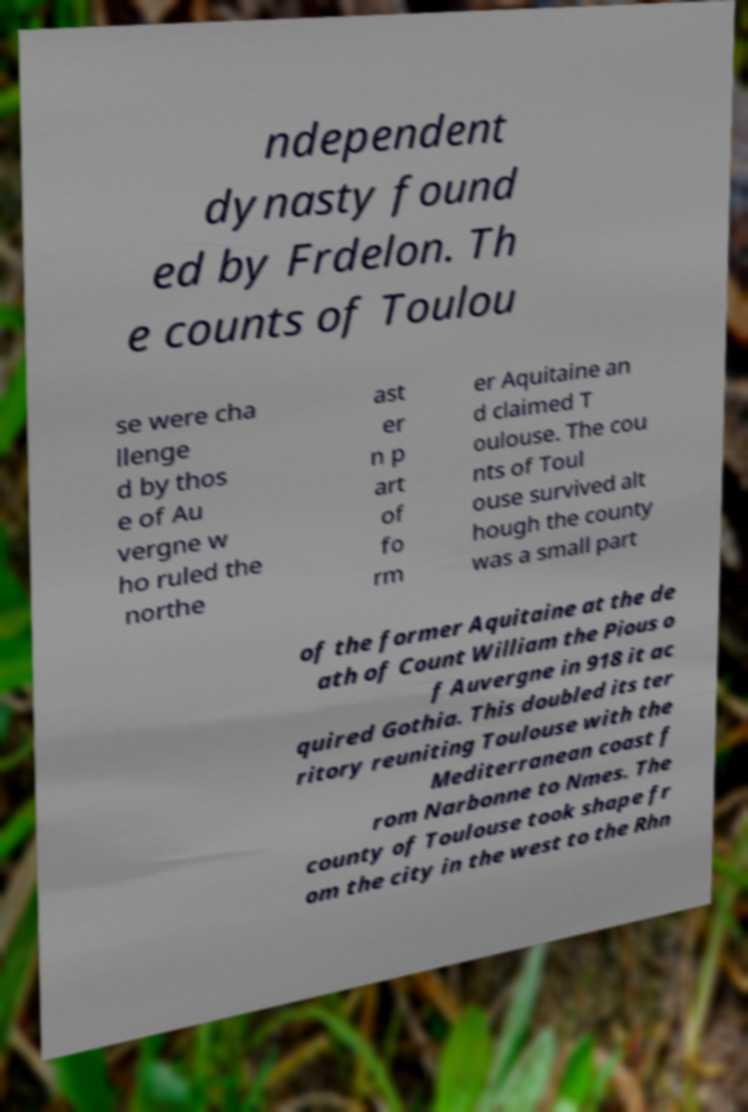Please identify and transcribe the text found in this image. ndependent dynasty found ed by Frdelon. Th e counts of Toulou se were cha llenge d by thos e of Au vergne w ho ruled the northe ast er n p art of fo rm er Aquitaine an d claimed T oulouse. The cou nts of Toul ouse survived alt hough the county was a small part of the former Aquitaine at the de ath of Count William the Pious o f Auvergne in 918 it ac quired Gothia. This doubled its ter ritory reuniting Toulouse with the Mediterranean coast f rom Narbonne to Nmes. The county of Toulouse took shape fr om the city in the west to the Rhn 